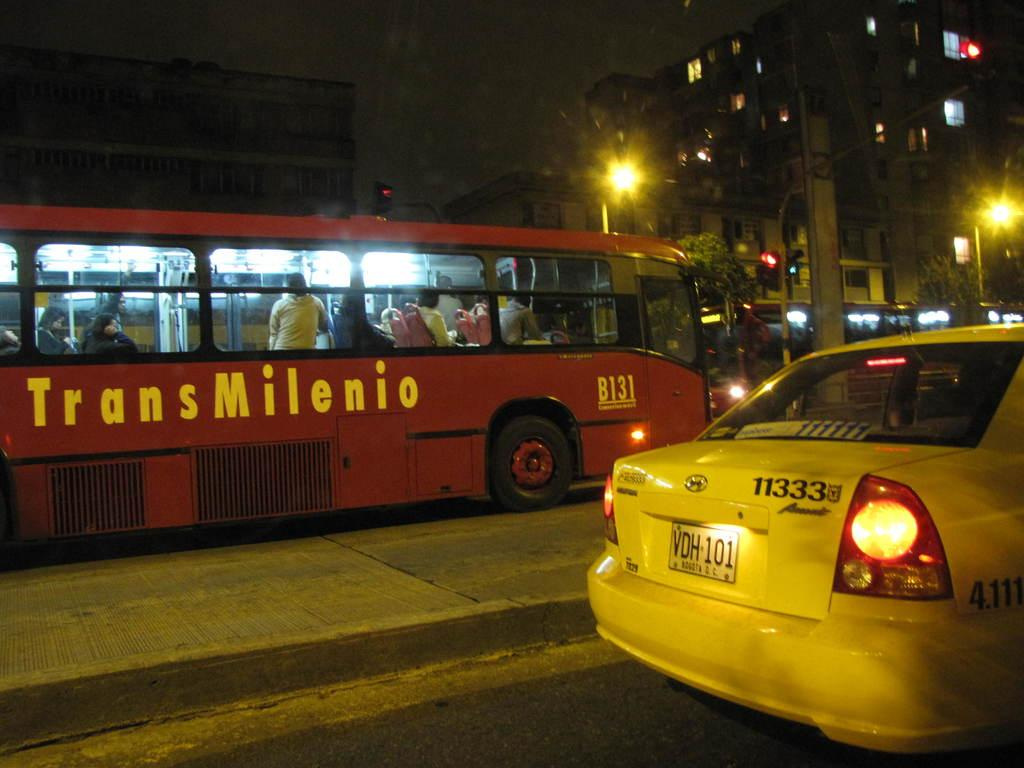<image>
Share a concise interpretation of the image provided. A red bus in the street with the yellow word Transmilenio on the side of it. 